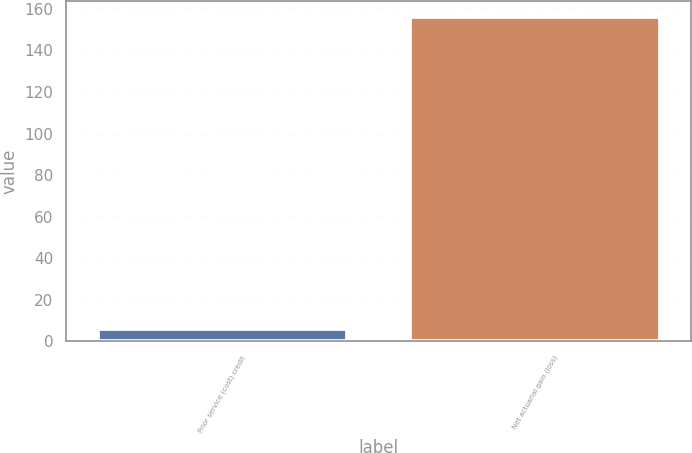<chart> <loc_0><loc_0><loc_500><loc_500><bar_chart><fcel>Prior service (cost) credit<fcel>Net actuarial gain (loss)<nl><fcel>6<fcel>156<nl></chart> 